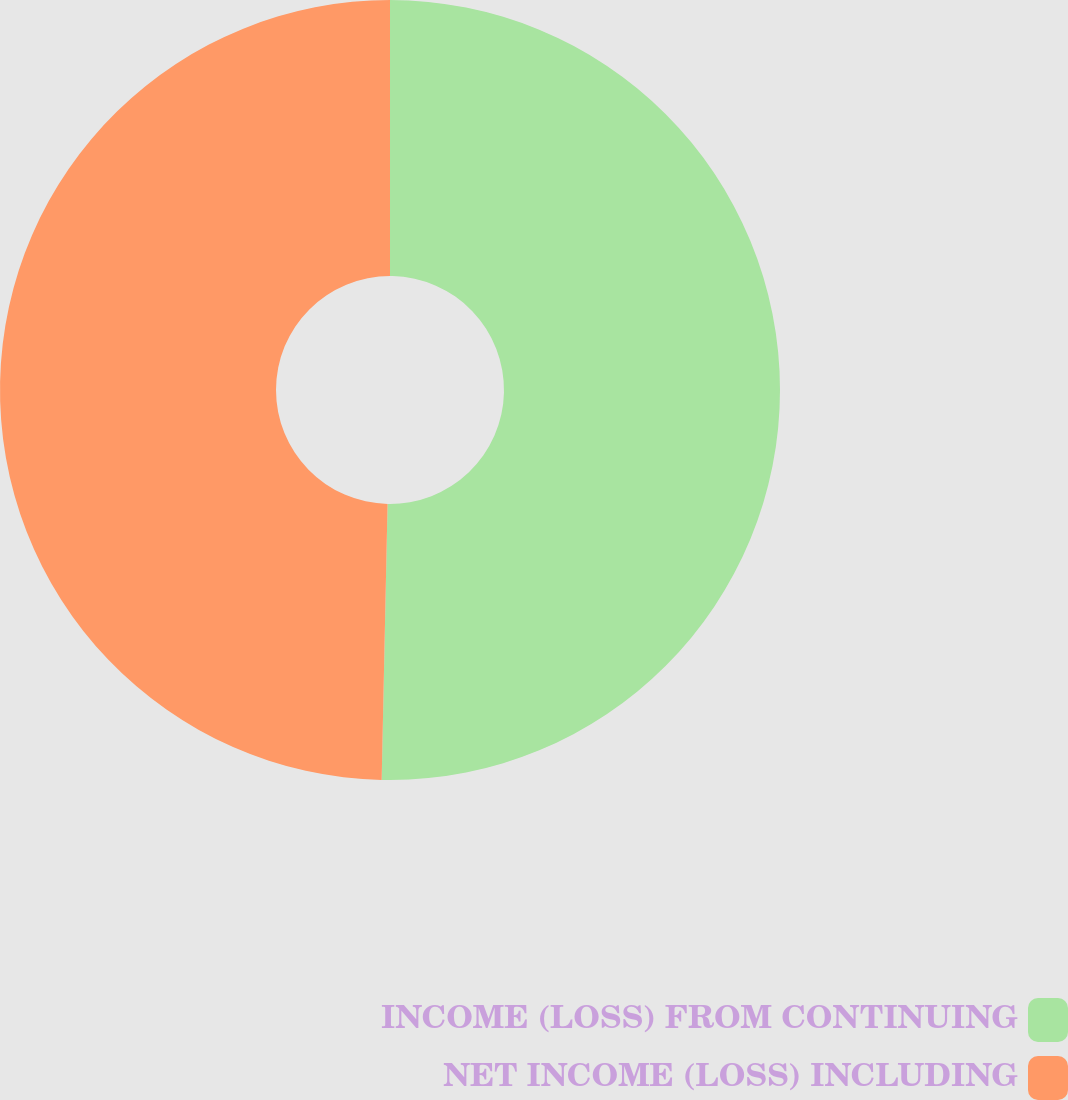<chart> <loc_0><loc_0><loc_500><loc_500><pie_chart><fcel>INCOME (LOSS) FROM CONTINUING<fcel>NET INCOME (LOSS) INCLUDING<nl><fcel>50.34%<fcel>49.66%<nl></chart> 